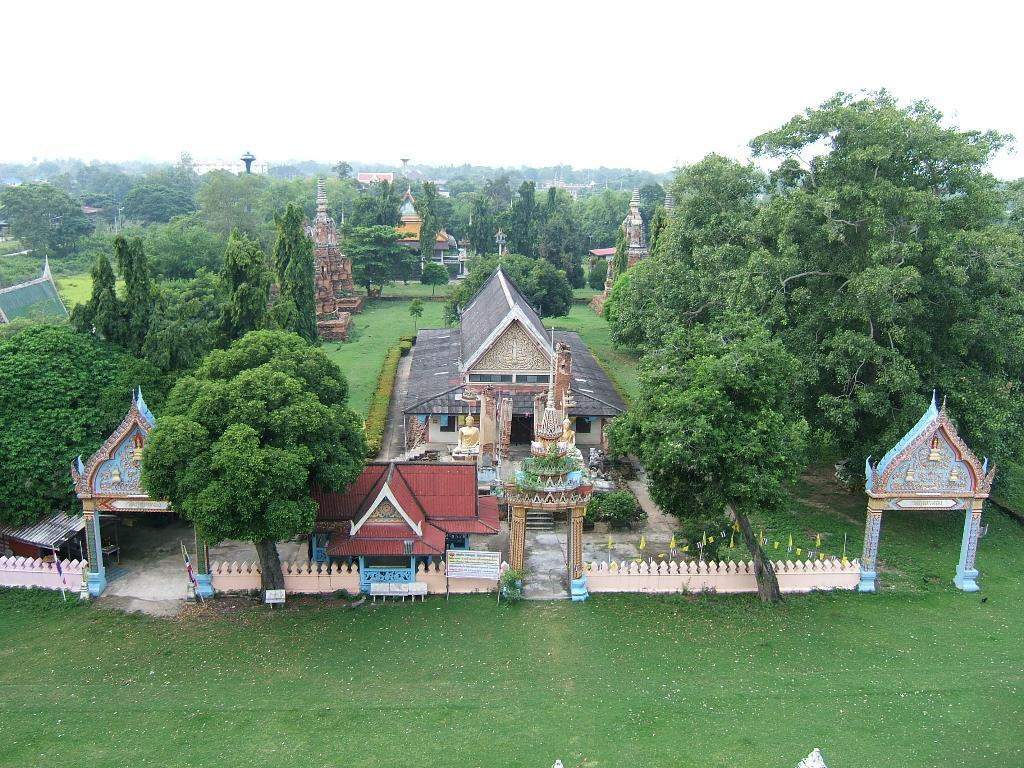What is the person in the image holding? The person is holding a phone. Where is the person standing in relation to the tree? The person is standing near a tree. Can you see a key hanging from the tree in the image? There is no key visible in the image; it only shows a person standing near a tree and holding a phone. 